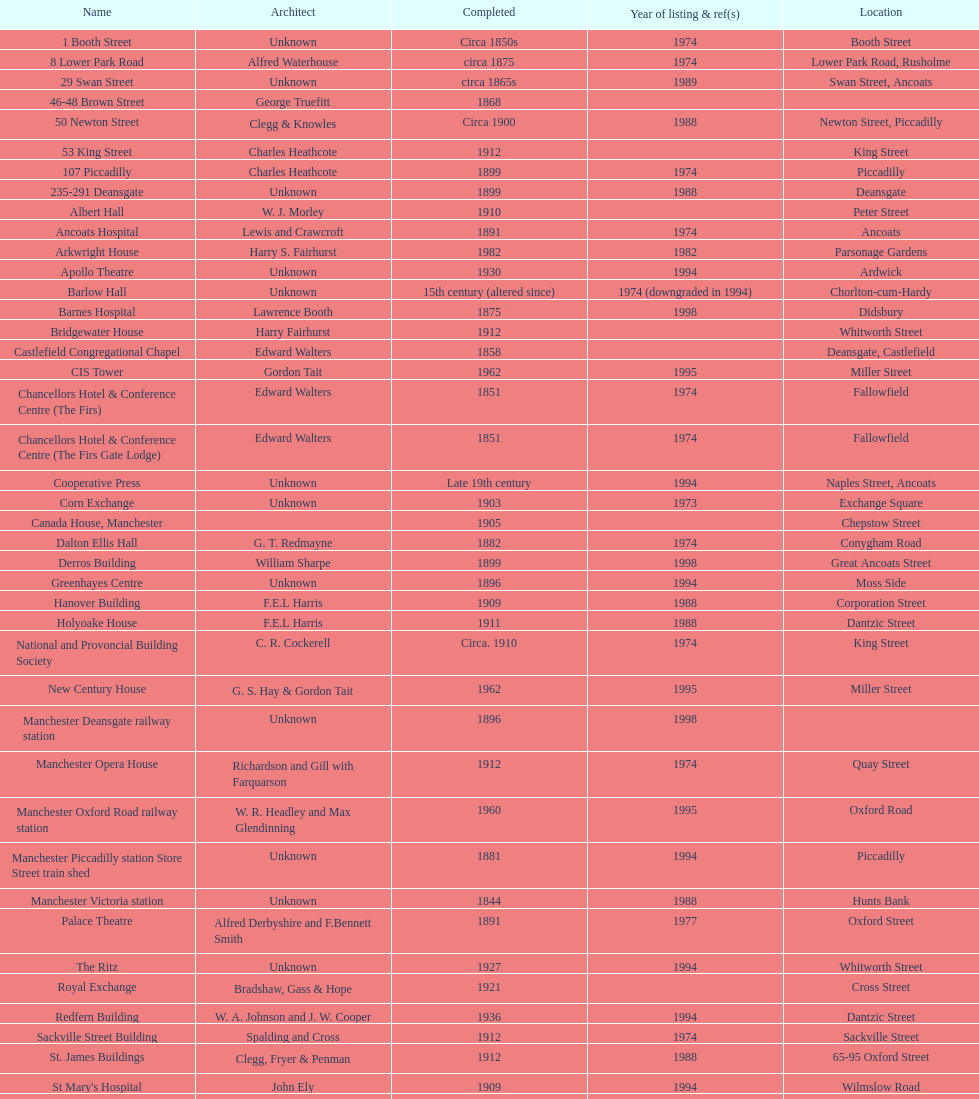How many buildings had alfred waterhouse as their architect? 3. 